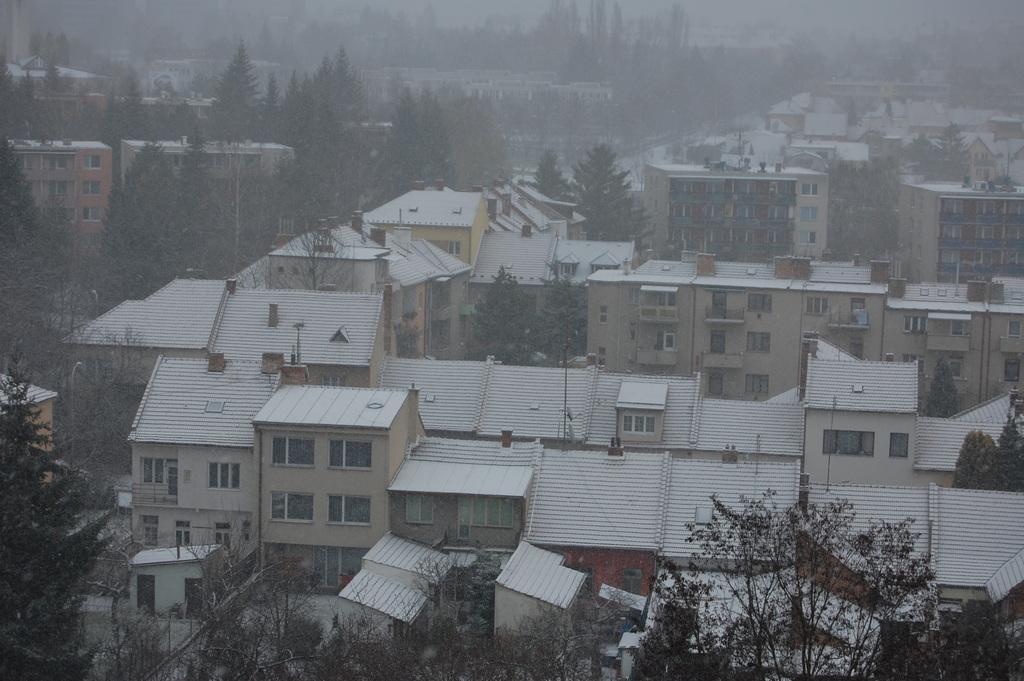What type of structures can be seen in the image? There are buildings in the image. What other elements are present in the image besides the buildings? There are trees in the image. How are the trees positioned in relation to the buildings? The trees are located between the buildings. What type of calendar is hanging on the tree in the image? There is no calendar present in the image; it only features buildings and trees. Can you see a duck swimming in the faucet in the image? There is no faucet or duck present in the image. 